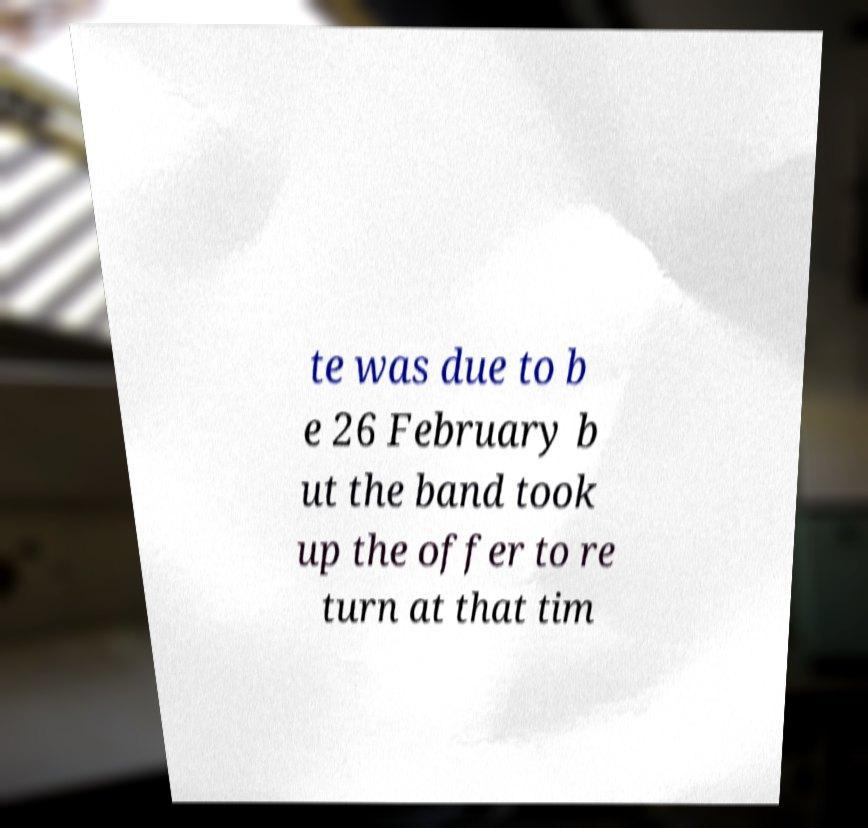Can you accurately transcribe the text from the provided image for me? te was due to b e 26 February b ut the band took up the offer to re turn at that tim 